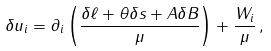Convert formula to latex. <formula><loc_0><loc_0><loc_500><loc_500>\delta u _ { i } = \partial _ { i } \left ( \frac { \delta \ell + \theta \delta s + A \delta B } \mu \right ) + \frac { W _ { i } } \mu \, ,</formula> 